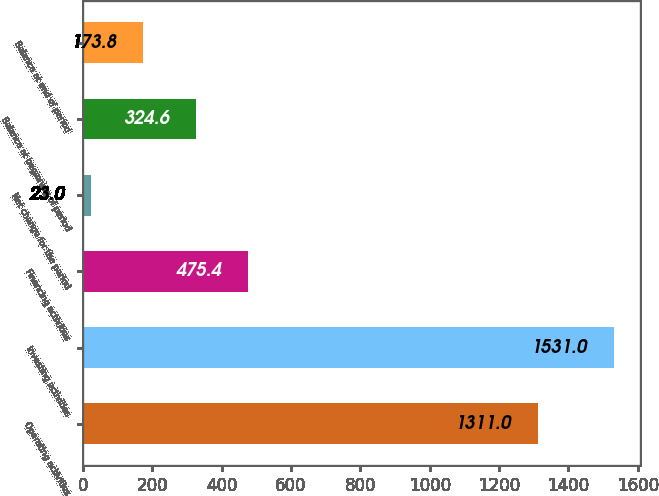Convert chart. <chart><loc_0><loc_0><loc_500><loc_500><bar_chart><fcel>Operating activities<fcel>Investing activities<fcel>Financing activities<fcel>Net change for the period<fcel>Balance at beginning of period<fcel>Balance at end of period<nl><fcel>1311<fcel>1531<fcel>475.4<fcel>23<fcel>324.6<fcel>173.8<nl></chart> 